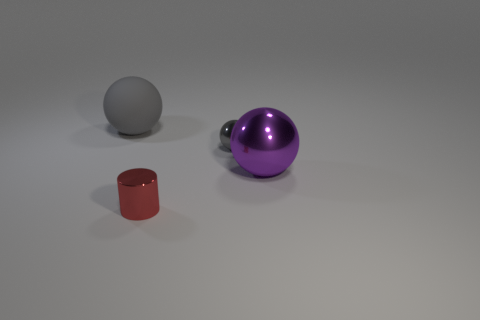What material is the big sphere that is on the left side of the sphere that is right of the tiny shiny object behind the purple metal ball made of?
Give a very brief answer. Rubber. How many large gray objects have the same material as the small red cylinder?
Offer a very short reply. 0. There is a matte object that is the same color as the small ball; what shape is it?
Offer a terse response. Sphere. The red object that is the same size as the gray shiny ball is what shape?
Offer a terse response. Cylinder. What is the material of the big thing that is the same color as the small metal ball?
Keep it short and to the point. Rubber. Are there any big gray things left of the big purple object?
Ensure brevity in your answer.  Yes. Is there a tiny shiny thing that has the same shape as the large gray object?
Give a very brief answer. Yes. Is the shape of the gray thing in front of the rubber thing the same as the metallic object on the left side of the gray shiny object?
Make the answer very short. No. Is there a gray rubber object that has the same size as the purple metal ball?
Provide a succinct answer. Yes. Are there the same number of large things that are on the left side of the small red metal object and big rubber objects that are in front of the large gray matte thing?
Your answer should be very brief. No. 